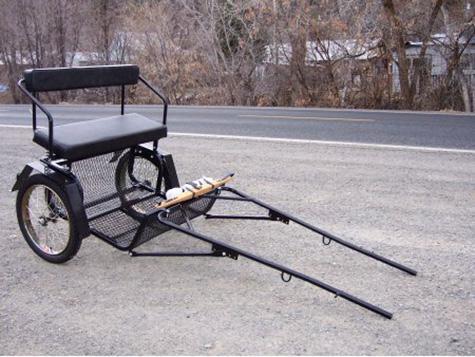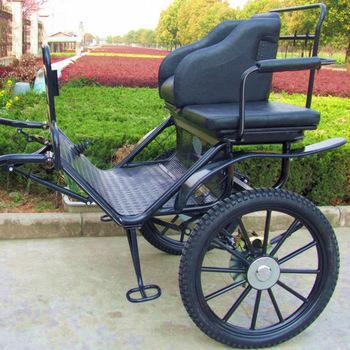The first image is the image on the left, the second image is the image on the right. Given the left and right images, does the statement "The front end of one of the carts is on the ground." hold true? Answer yes or no. Yes. The first image is the image on the left, the second image is the image on the right. Examine the images to the left and right. Is the description "In one image, the 'handles' of the wagon are tilted to the ground." accurate? Answer yes or no. Yes. 